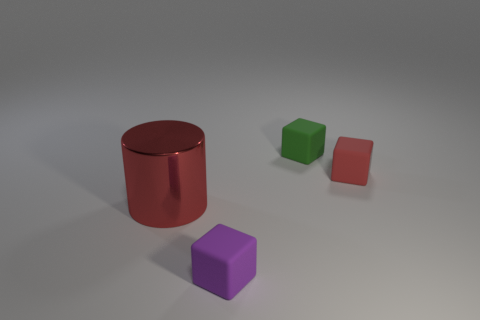How many large things are to the left of the red object on the left side of the tiny matte object that is in front of the large metallic cylinder?
Give a very brief answer. 0. What material is the small green object that is the same shape as the small purple rubber object?
Offer a very short reply. Rubber. Are there any other things that are the same material as the small green cube?
Give a very brief answer. Yes. There is a cube that is right of the tiny green matte cube; what color is it?
Provide a succinct answer. Red. Is the material of the tiny purple block the same as the red thing on the left side of the green rubber block?
Provide a short and direct response. No. What is the small green thing made of?
Offer a very short reply. Rubber. There is a red object that is the same material as the tiny purple cube; what shape is it?
Offer a terse response. Cube. How many other objects are there of the same shape as the red matte object?
Give a very brief answer. 2. What number of small green matte objects are right of the red rubber object?
Ensure brevity in your answer.  0. There is a red object that is right of the tiny purple matte thing; is its size the same as the red object left of the small purple thing?
Offer a terse response. No. 